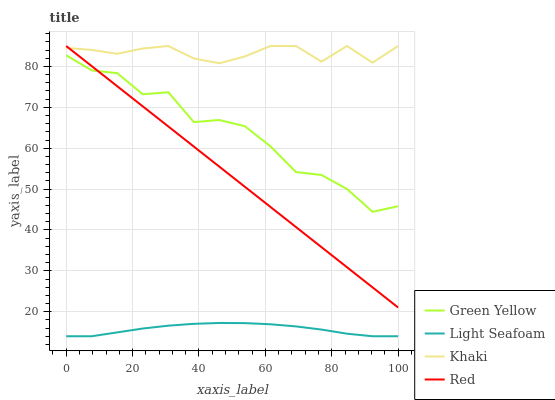Does Light Seafoam have the minimum area under the curve?
Answer yes or no. Yes. Does Khaki have the maximum area under the curve?
Answer yes or no. Yes. Does Green Yellow have the minimum area under the curve?
Answer yes or no. No. Does Green Yellow have the maximum area under the curve?
Answer yes or no. No. Is Red the smoothest?
Answer yes or no. Yes. Is Green Yellow the roughest?
Answer yes or no. Yes. Is Khaki the smoothest?
Answer yes or no. No. Is Khaki the roughest?
Answer yes or no. No. Does Light Seafoam have the lowest value?
Answer yes or no. Yes. Does Green Yellow have the lowest value?
Answer yes or no. No. Does Khaki have the highest value?
Answer yes or no. Yes. Does Green Yellow have the highest value?
Answer yes or no. No. Is Light Seafoam less than Red?
Answer yes or no. Yes. Is Green Yellow greater than Light Seafoam?
Answer yes or no. Yes. Does Red intersect Green Yellow?
Answer yes or no. Yes. Is Red less than Green Yellow?
Answer yes or no. No. Is Red greater than Green Yellow?
Answer yes or no. No. Does Light Seafoam intersect Red?
Answer yes or no. No. 